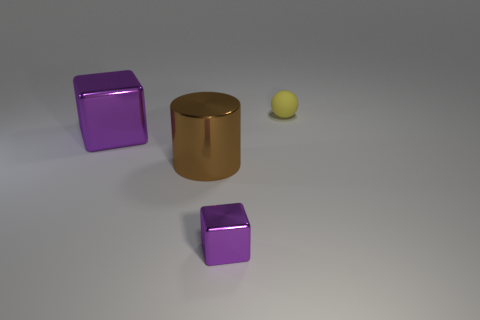Add 4 large brown objects. How many objects exist? 8 Subtract all balls. How many objects are left? 3 Subtract 0 blue blocks. How many objects are left? 4 Subtract all large blocks. Subtract all cyan cubes. How many objects are left? 3 Add 3 purple metal objects. How many purple metal objects are left? 5 Add 4 large brown things. How many large brown things exist? 5 